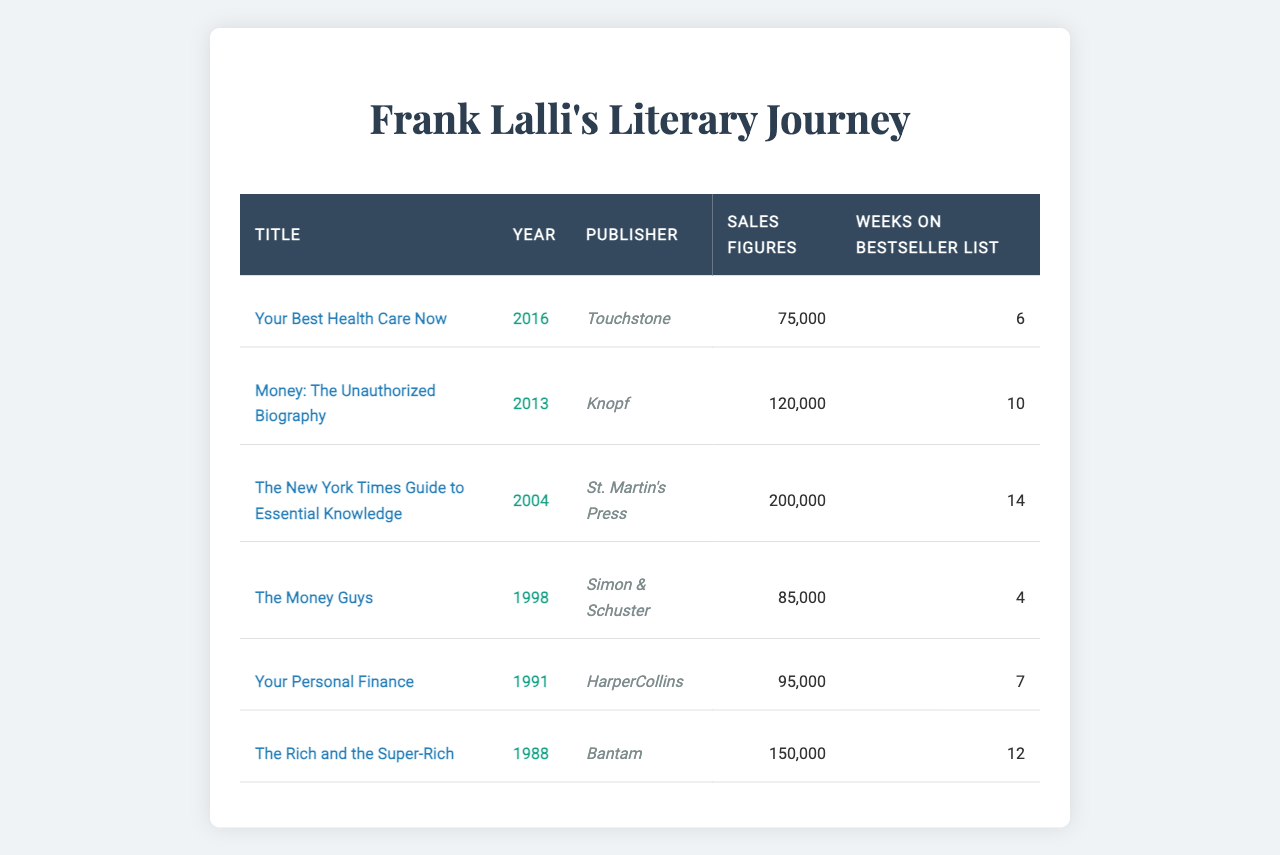What is the title of the book published in 2016? To find the title of the book published in 2016, I look at the year column in the table, which shows "2016" next to the title "Your Best Health Care Now".
Answer: Your Best Health Care Now Which book has the highest sales figures? Scanning the sales figures in the table, "The New York Times Guide to Essential Knowledge" has the highest figure of 200,000.
Answer: The New York Times Guide to Essential Knowledge How many weeks did "Money: The Unauthorized Biography" spend on the bestseller list? The table shows that "Money: The Unauthorized Biography" spent 10 weeks on the bestseller list, which can be found in the corresponding column.
Answer: 10 weeks What is the total sales figure for all books published by Frank Lalli? Adding the sales figures, (75,000 + 120,000 + 200,000 + 85,000 + 95,000 + 150,000) results in 725,000.
Answer: 725,000 Which publisher published the book with the least weeks on the bestseller list? Looking at the “weeks on bestseller list” column, "The Money Guys" by Simon & Schuster has the least at 4 weeks.
Answer: Simon & Schuster Is "Your Best Health Care Now" listed as published by HarperCollins? Reviewing the publisher column for "Your Best Health Care Now", it is published by Touchstone, not HarperCollins.
Answer: No What is the average number of weeks on the bestseller list for all books? To calculate the average, I sum the weeks (6 + 10 + 14 + 4 + 7 + 12 = 53) and divide by the number of books (6), yielding approximately 8.83 weeks.
Answer: 8.83 weeks What year was "The Rich and the Super-Rich" published? Looking at the table, "The Rich and the Super-Rich" was published in 1988, which is clearly listed in the year column.
Answer: 1988 How many books had sales figures above 100,000? Checking the sales figures, there are three books above 100,000, namely "Money: The Unauthorized Biography", "The New York Times Guide to Essential Knowledge", and "The Rich and the Super-Rich".
Answer: 3 books Which book has the same publisher as "Your Personal Finance"? The table indicates that both "Your Personal Finance" and "Your Best Health Care Now" are published by different publishers, namely HarperCollins and Touchstone respectively, indicating no overlap.
Answer: None 